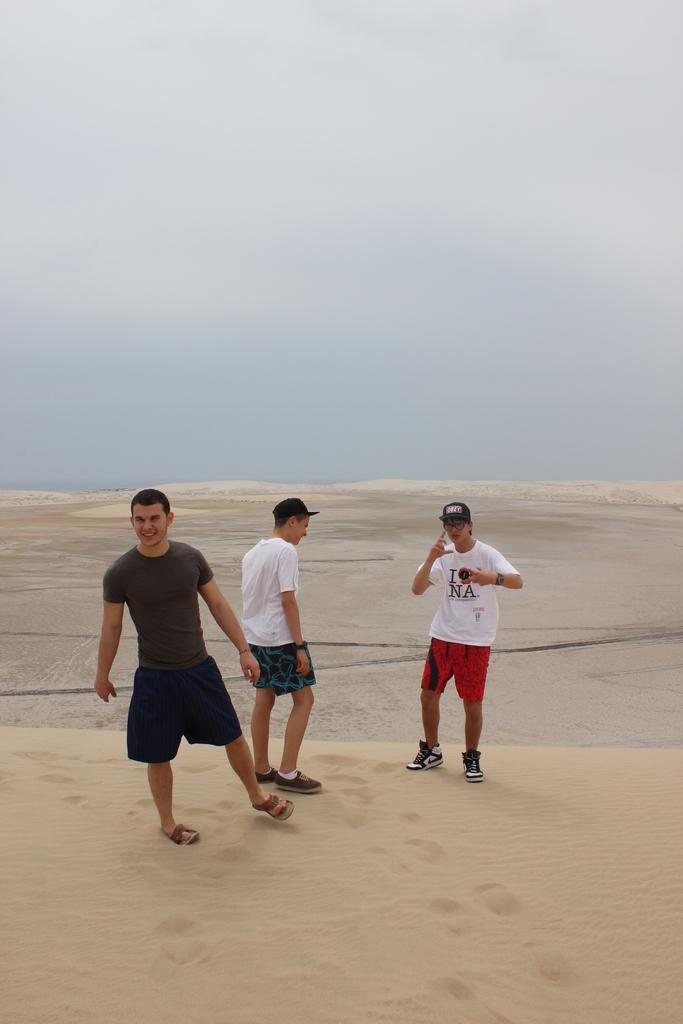How many people are in the image? There are three people standing in the center of the image. What is at the bottom of the image? There is sand at the bottom of the image. What is visible at the top of the image? The sky is visible at the top of the image. What type of gun is being used by the people in the image? There is no gun present in the image; the three people are simply standing in the center. 